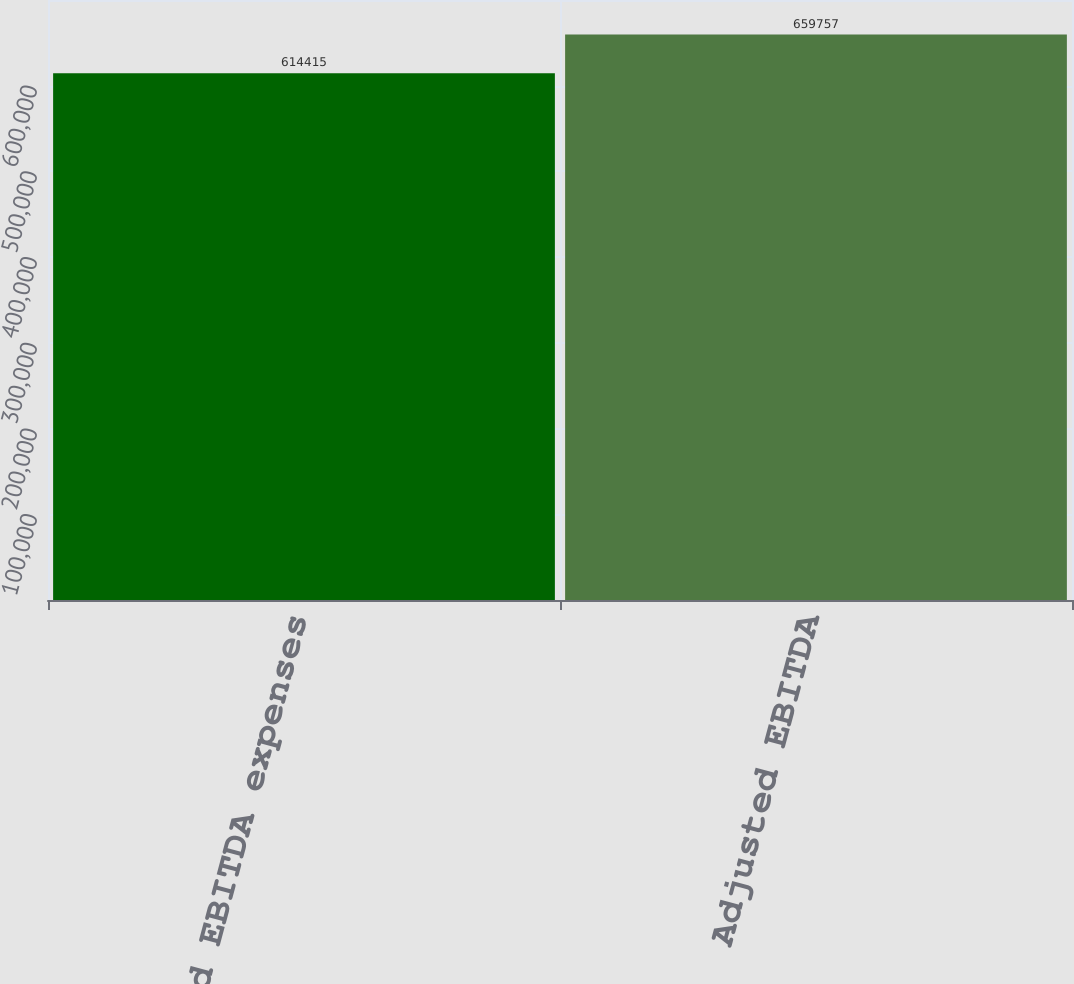Convert chart. <chart><loc_0><loc_0><loc_500><loc_500><bar_chart><fcel>Adjusted EBITDA expenses<fcel>Adjusted EBITDA<nl><fcel>614415<fcel>659757<nl></chart> 